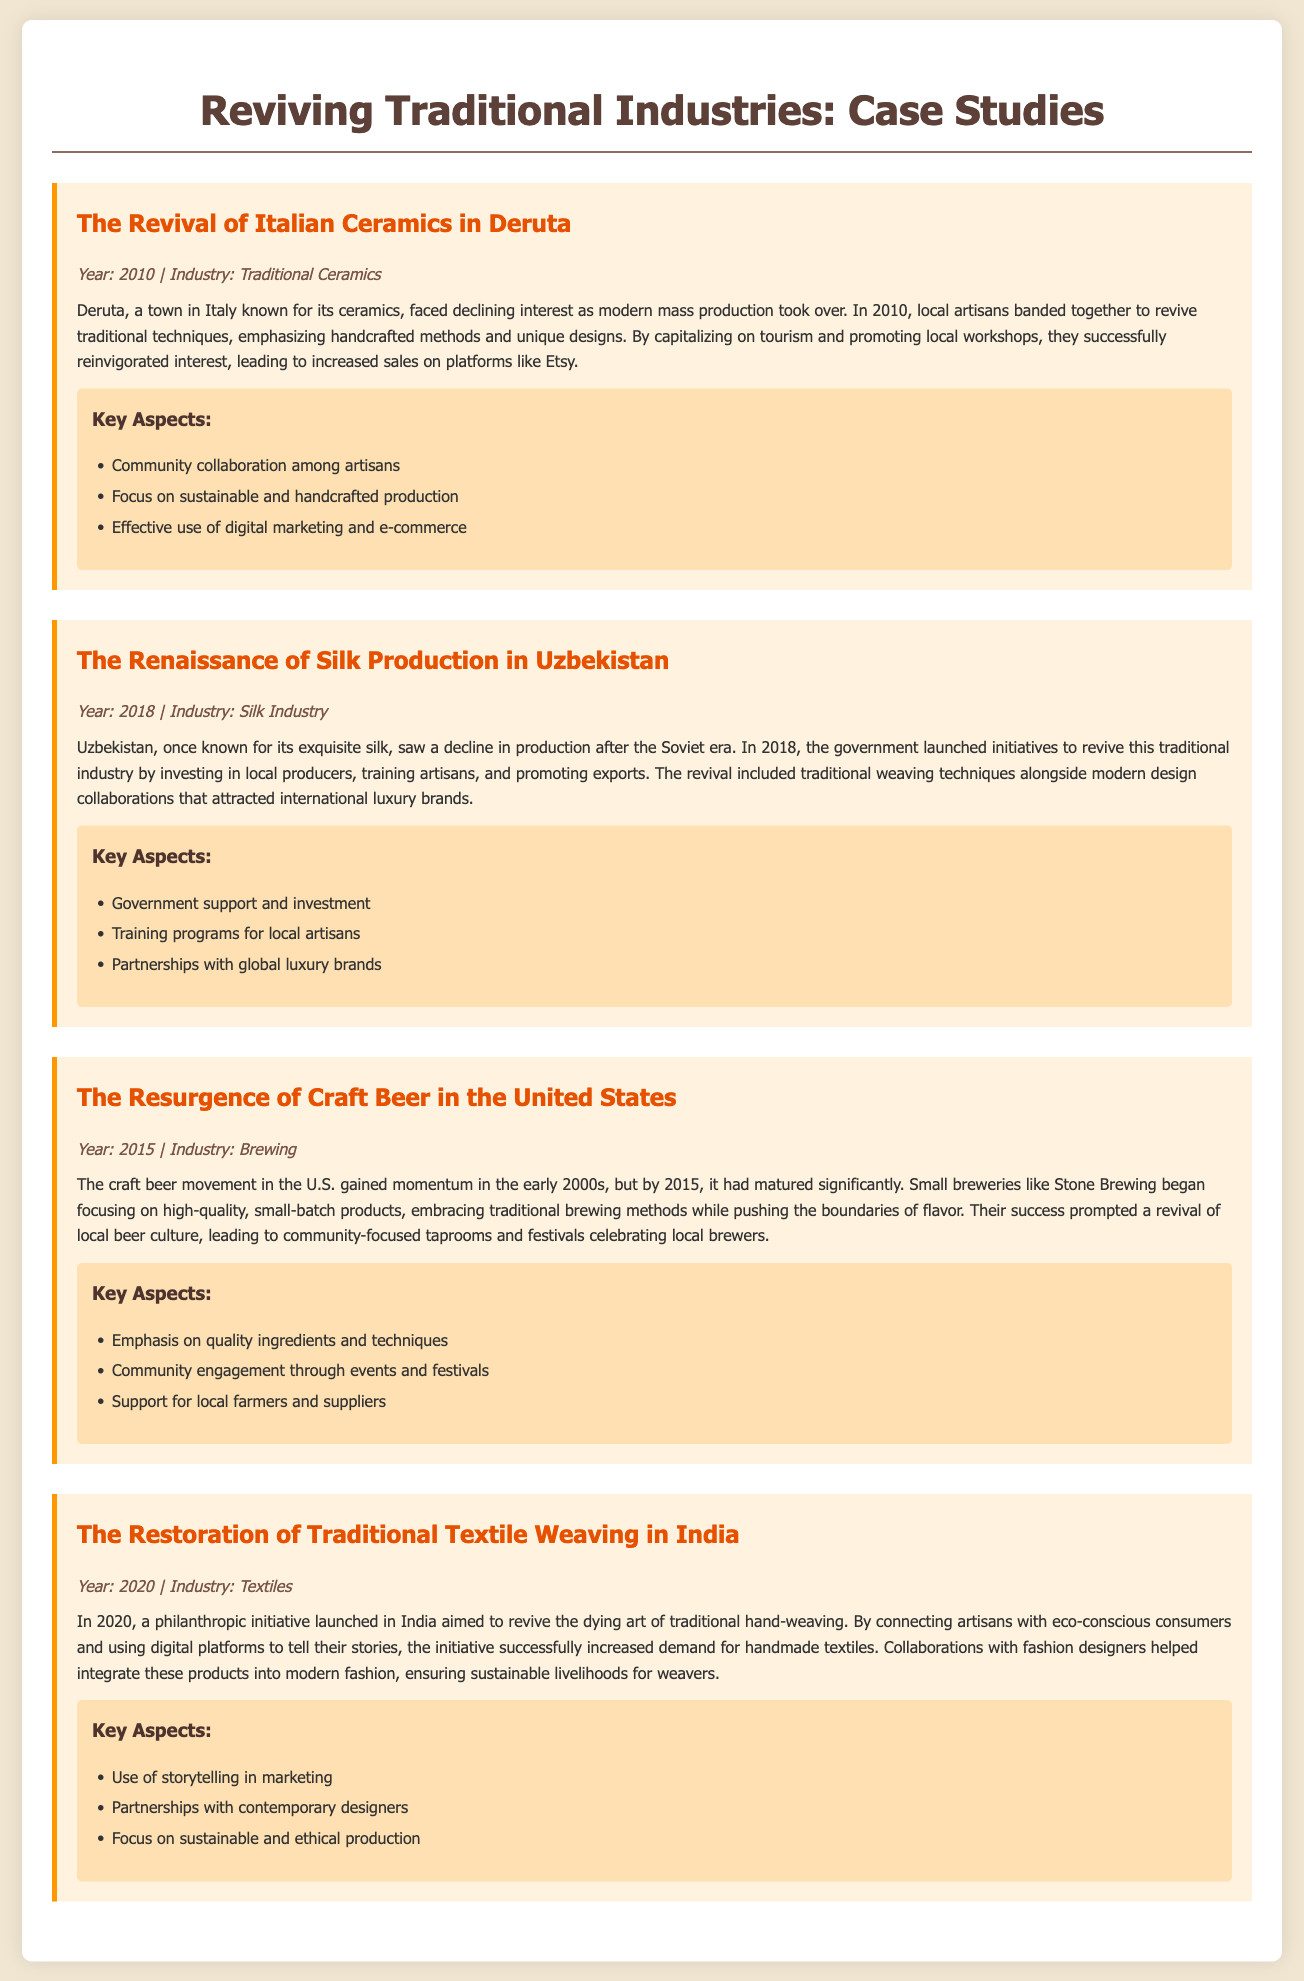What year did the revival of Italian Ceramics in Deruta occur? The document states that the revival happened in 2010.
Answer: 2010 What industry is associated with the case study from Uzbekistan? The document identifies the industry related to Uzbekistan as the Silk Industry.
Answer: Silk Industry Which company is mentioned in the craft beer case study? Stone Brewing is highlighted in the case study regarding craft beer.
Answer: Stone Brewing What is one key aspect of the restoration of traditional textile weaving in India? The document lists storytelling in marketing as a key aspect of the initiative in India.
Answer: Storytelling In what year did the resurgence of craft beer occur? The document mentions that this resurgence reached maturity in 2015.
Answer: 2015 How did the artisans in Deruta increase sales? The document indicates they used digital marketing and e-commerce to boost sales.
Answer: Digital marketing and e-commerce What type of support was provided by the government in Uzbekistan's silk revival? The government support included investment to assist local producers.
Answer: Investment What strategy was used to connect artisans with consumers in India? The document explains that the initiative used digital platforms to tell artisans' stories.
Answer: Digital platforms What was a primary focus of the craft beer movement in the United States? The key focus listed is on quality ingredients and techniques.
Answer: Quality ingredients and techniques 